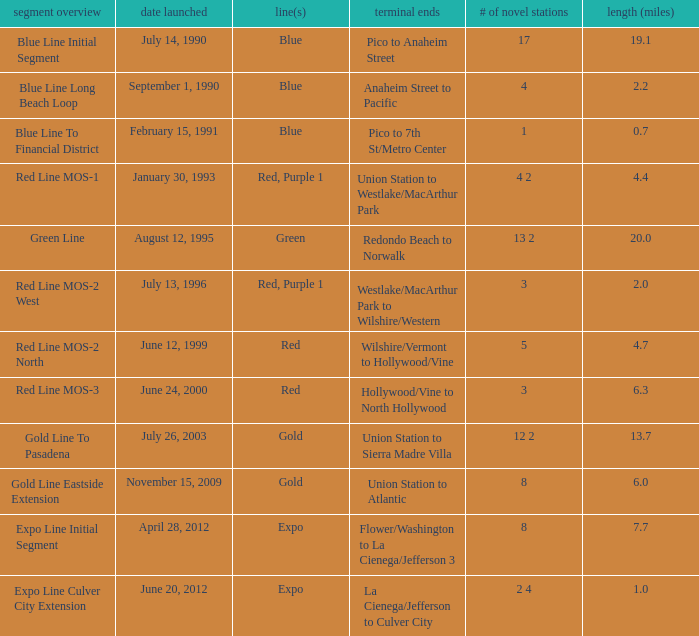How many lines have the segment description of red line mos-2 west? Red, Purple 1. 